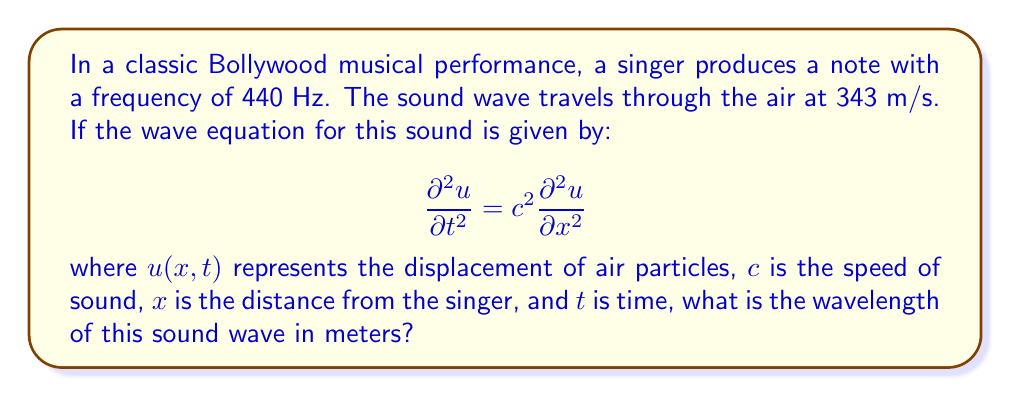Provide a solution to this math problem. Let's approach this step-by-step:

1) We know that the wave equation is given by:
   $$\frac{\partial^2 u}{\partial t^2} = c^2 \frac{\partial^2 u}{\partial x^2}$$

2) For a simple harmonic wave, the general solution is of the form:
   $$u(x,t) = A \sin(kx - \omega t)$$
   where $k$ is the wave number and $\omega$ is the angular frequency.

3) The wave number $k$ is related to the wavelength $\lambda$ by:
   $$k = \frac{2\pi}{\lambda}$$

4) The angular frequency $\omega$ is related to the frequency $f$ by:
   $$\omega = 2\pi f$$

5) For waves, we have the relationship:
   $$c = f\lambda$$
   where $c$ is the speed of the wave, $f$ is the frequency, and $\lambda$ is the wavelength.

6) We are given:
   $c = 343$ m/s (speed of sound in air)
   $f = 440$ Hz (frequency of the note)

7) Rearranging the wave equation:
   $$\lambda = \frac{c}{f}$$

8) Substituting the values:
   $$\lambda = \frac{343}{440} \approx 0.78$$

Therefore, the wavelength of the sound wave is approximately 0.78 meters.
Answer: 0.78 m 